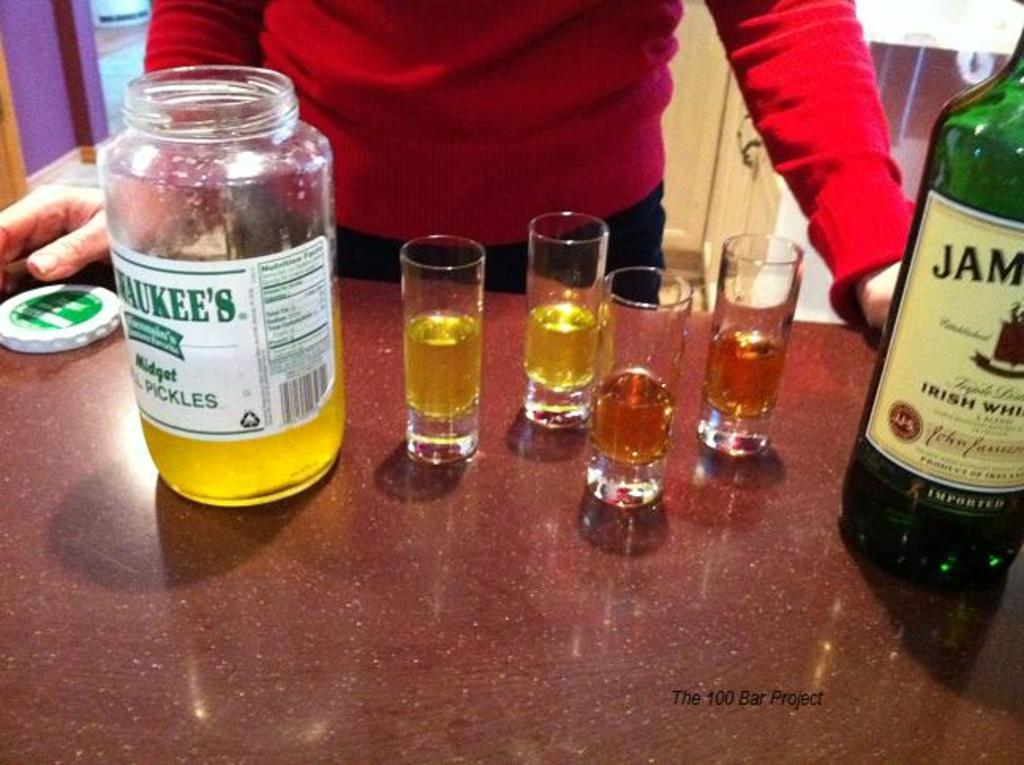<image>
Present a compact description of the photo's key features. Both Pickle Juice and Jameson is poured into several shot glasses side by side. 